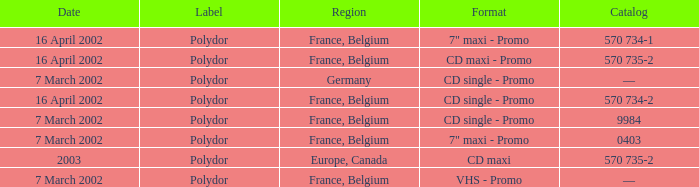Which region had a catalog number of 570 734-2? France, Belgium. 